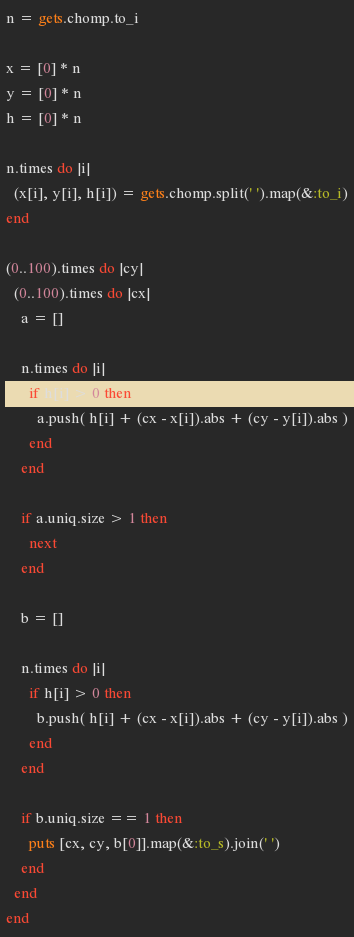<code> <loc_0><loc_0><loc_500><loc_500><_Ruby_>n = gets.chomp.to_i

x = [0] * n
y = [0] * n
h = [0] * n

n.times do |i|
  (x[i], y[i], h[i]) = gets.chomp.split(' ').map(&:to_i)
end

(0..100).times do |cy|
  (0..100).times do |cx|
    a = []
    
    n.times do |i|  
      if h[i] > 0 then
        a.push( h[i] + (cx - x[i]).abs + (cy - y[i]).abs )
      end
    end
    
    if a.uniq.size > 1 then
      next
    end
    
    b = []
    
    n.times do |i|
      if h[i] > 0 then
        b.push( h[i] + (cx - x[i]).abs + (cy - y[i]).abs )
      end
    end
    
    if b.uniq.size == 1 then
      puts [cx, cy, b[0]].map(&:to_s).join(' ')
    end
  end
end</code> 